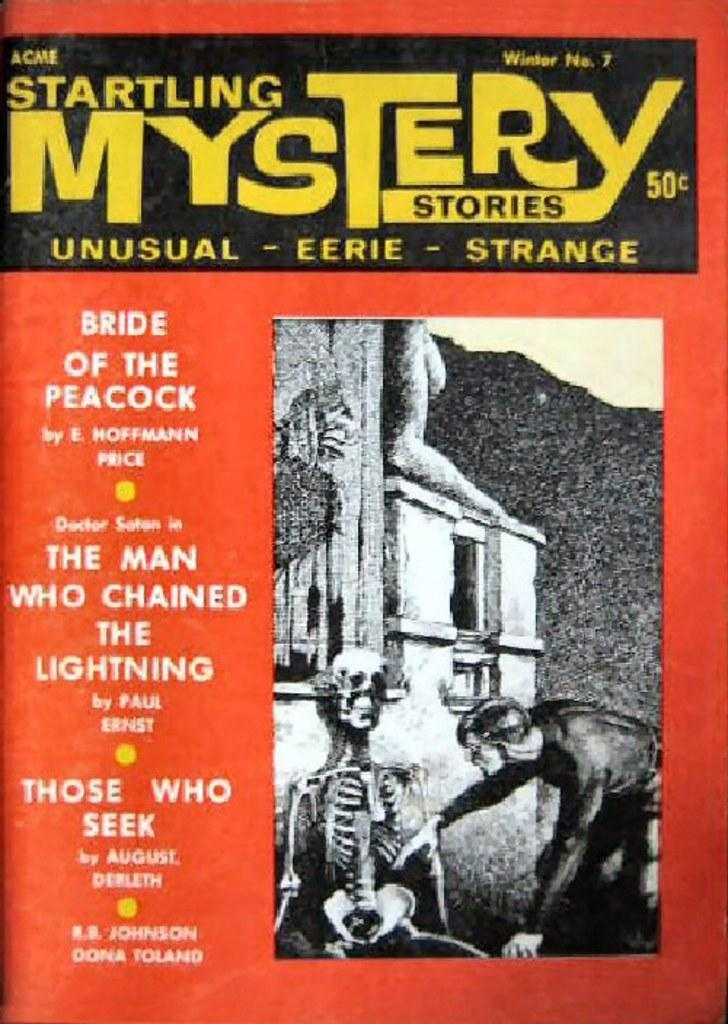What is featured on the poster in the image? The poster contains a picture of a person and a skeleton. What else can be found on the poster besides the images? There is text on the poster. What type of structure is visible in the image? There is a building visible in the image. How many seeds can be seen growing on the skeleton in the image? There are no seeds present in the image, as it features a poster with a picture of a person and a skeleton, and no seeds are visible. 